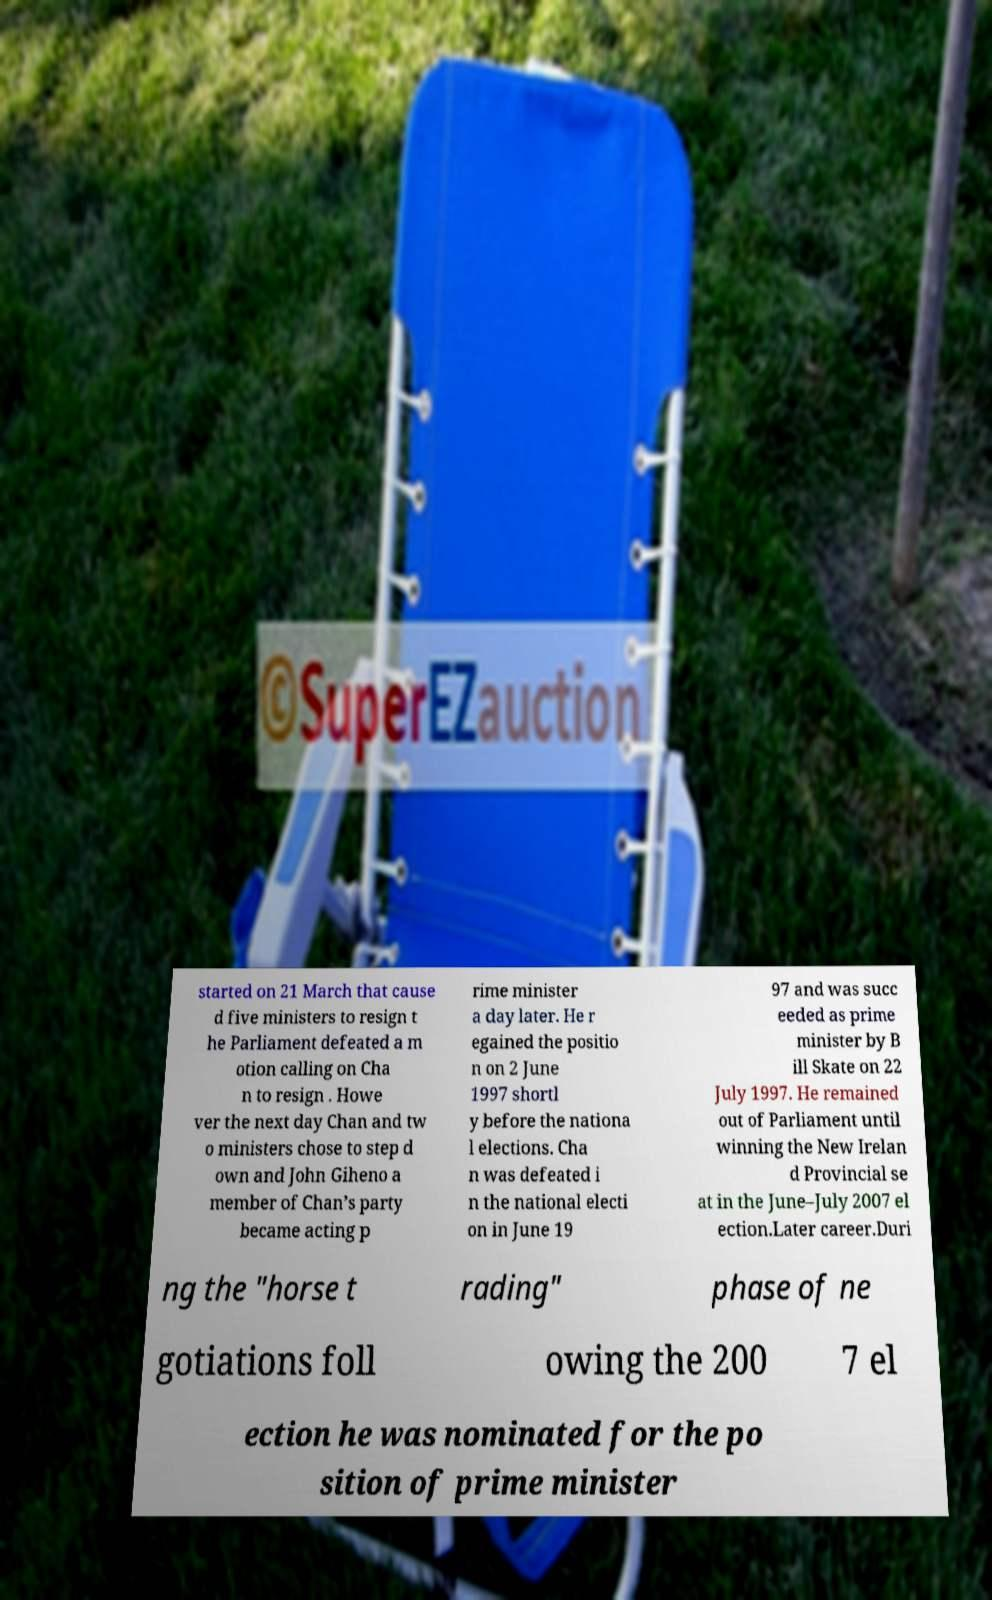Please read and relay the text visible in this image. What does it say? started on 21 March that cause d five ministers to resign t he Parliament defeated a m otion calling on Cha n to resign . Howe ver the next day Chan and tw o ministers chose to step d own and John Giheno a member of Chan’s party became acting p rime minister a day later. He r egained the positio n on 2 June 1997 shortl y before the nationa l elections. Cha n was defeated i n the national electi on in June 19 97 and was succ eeded as prime minister by B ill Skate on 22 July 1997. He remained out of Parliament until winning the New Irelan d Provincial se at in the June–July 2007 el ection.Later career.Duri ng the "horse t rading" phase of ne gotiations foll owing the 200 7 el ection he was nominated for the po sition of prime minister 